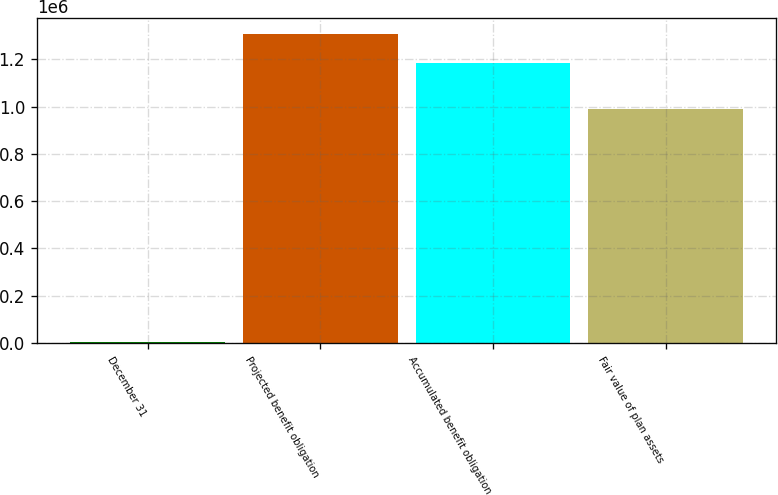Convert chart to OTSL. <chart><loc_0><loc_0><loc_500><loc_500><bar_chart><fcel>December 31<fcel>Projected benefit obligation<fcel>Accumulated benefit obligation<fcel>Fair value of plan assets<nl><fcel>2012<fcel>1.30874e+06<fcel>1.18521e+06<fcel>987643<nl></chart> 